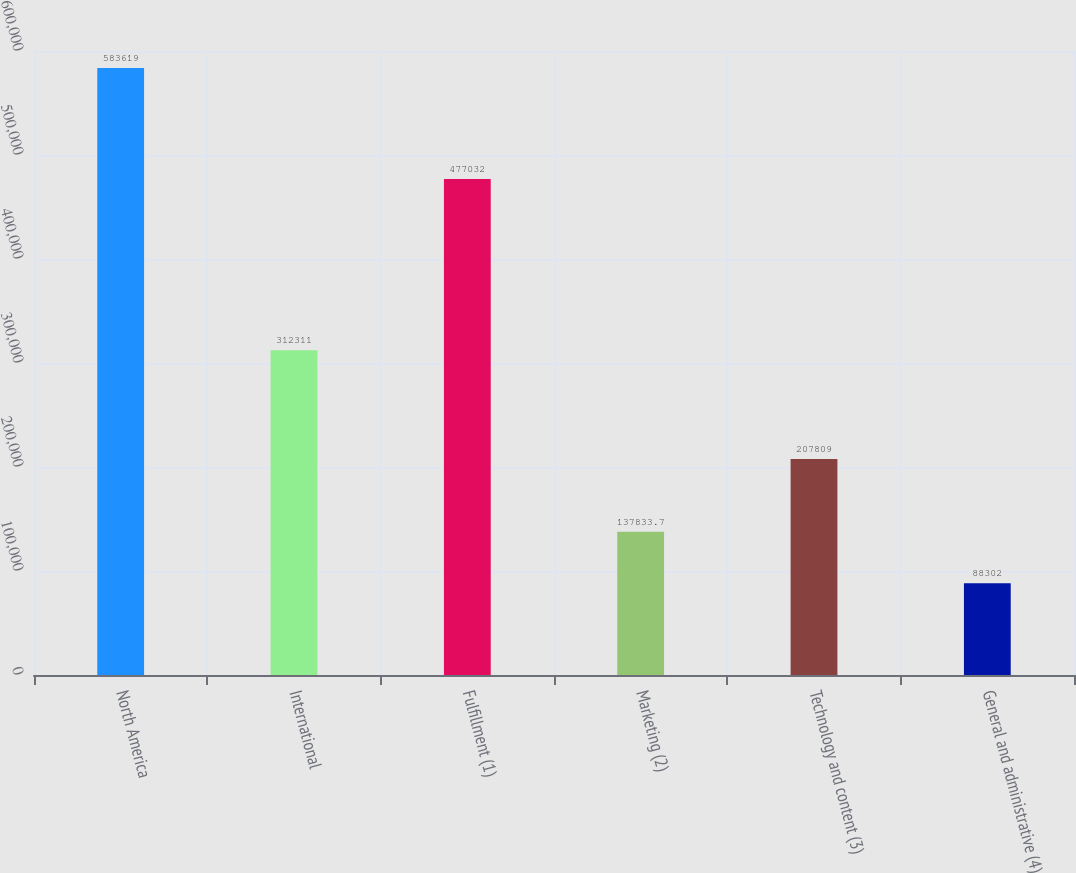Convert chart to OTSL. <chart><loc_0><loc_0><loc_500><loc_500><bar_chart><fcel>North America<fcel>International<fcel>Fulfillment (1)<fcel>Marketing (2)<fcel>Technology and content (3)<fcel>General and administrative (4)<nl><fcel>583619<fcel>312311<fcel>477032<fcel>137834<fcel>207809<fcel>88302<nl></chart> 